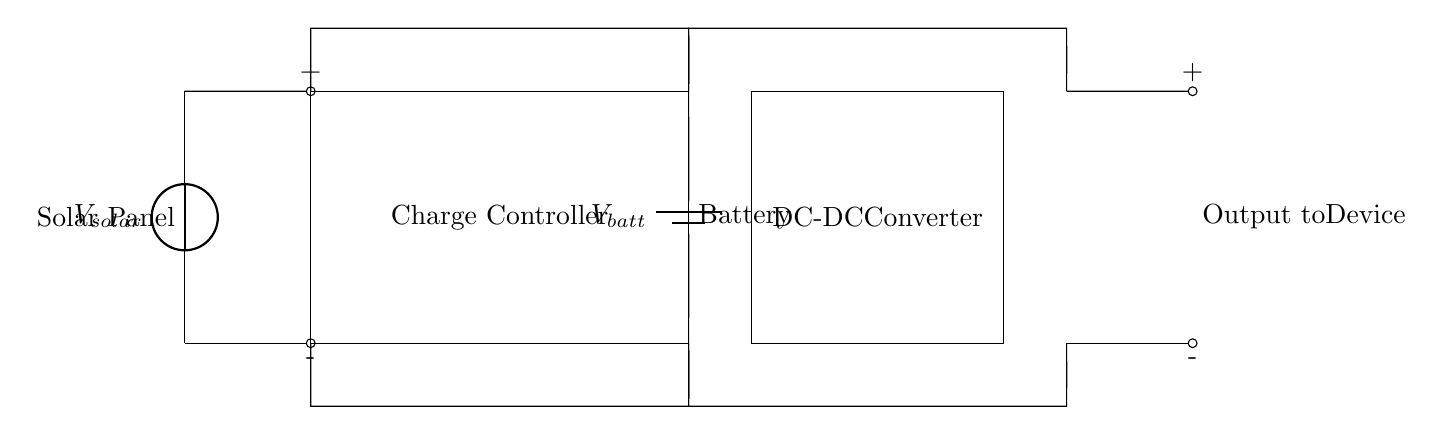What is the voltage source in this circuit? The voltage source in this circuit is the solar panel labeled as V solar, which indicates it provides the required electrical energy for charging.
Answer: V solar What component is used to store electrical energy? The component used to store electrical energy in this circuit is the battery, which is labeled as V batt.
Answer: Battery What type of circuit is this? This circuit is a solar-powered battery charging circuit designed for portable communication devices, involving a solar panel, a charge controller, and a converter.
Answer: Solar-powered What is the purpose of the charge controller? The charge controller regulates the voltage and current coming from the solar panel to protect the battery from overcharging or excessive discharge.
Answer: Regulation Where does the output go in this circuit? The output from the circuit, indicated by components at the end, goes directly to the device that requires power, hence labeled "Output to Device."
Answer: To device What component converts the battery voltage to a usable voltage? The component that converts the battery voltage to a usable voltage is the DC-DC converter situated after the battery.
Answer: DC-DC converter What do the short lines represent in this diagram? The short lines represent electrical connections between various components in the circuit indicating how they are wired together.
Answer: Connections 